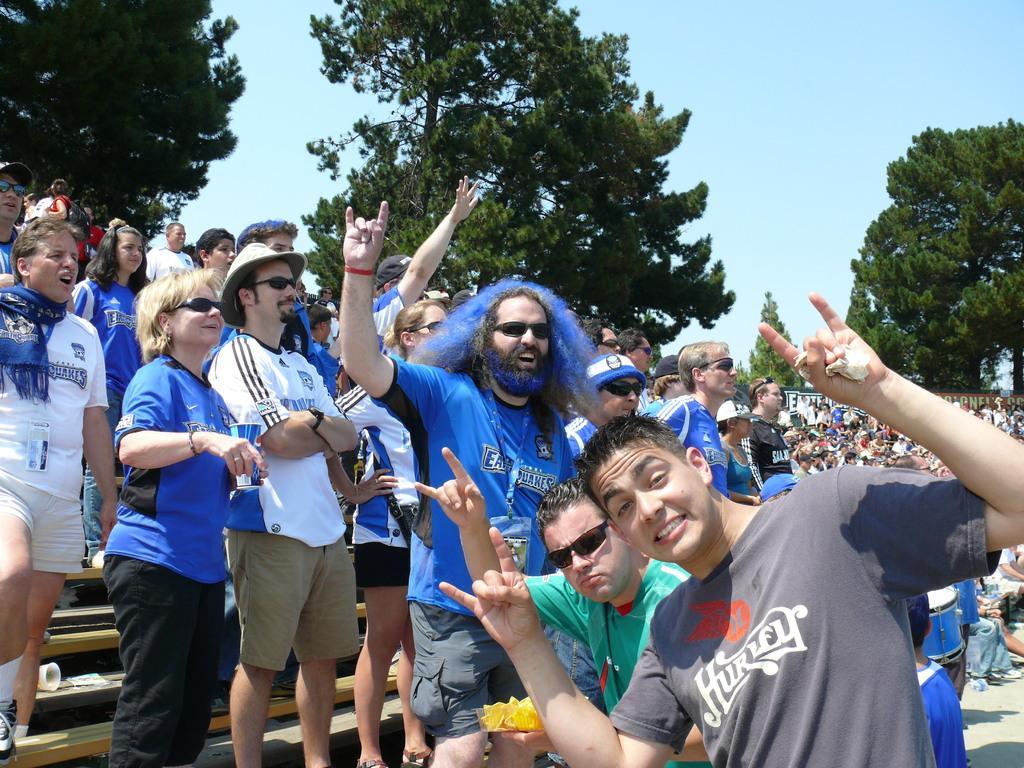Can you describe this image briefly? In this image we can see many people and few people holding some objects in their hands. There are many trees in the image. We can see the sky in the image. 